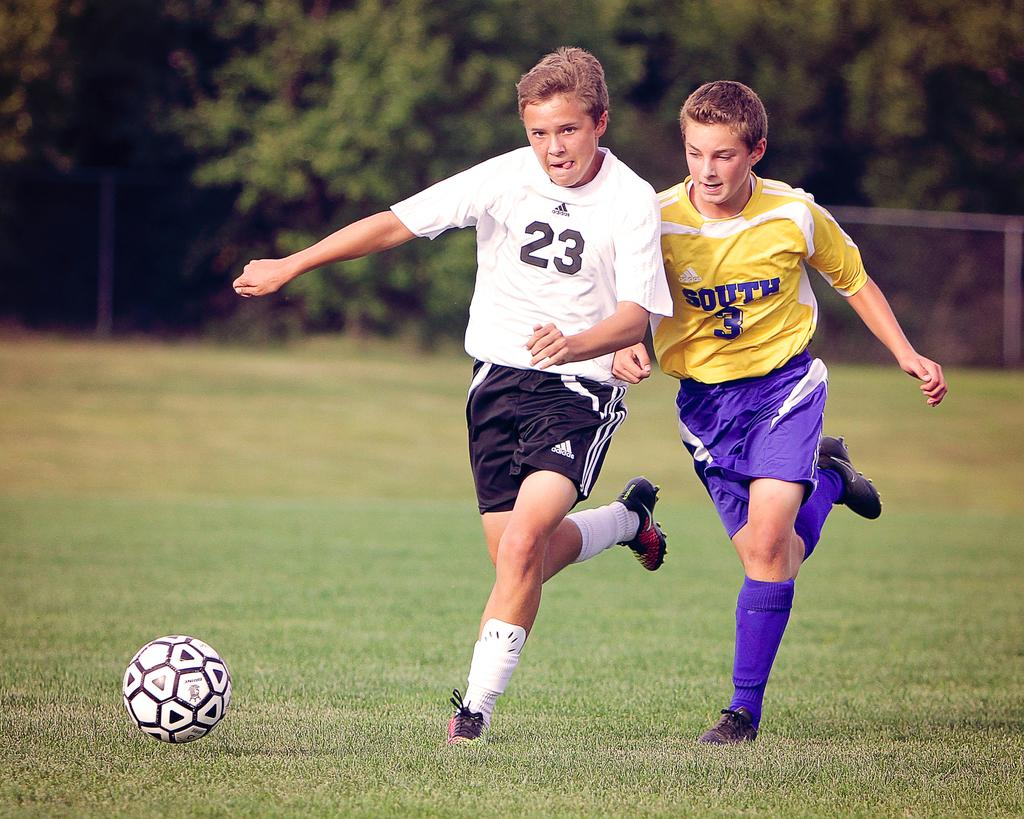Provide a one-sentence caption for the provided image. Soccer player wearing number 23 next to one wearing number 3. 